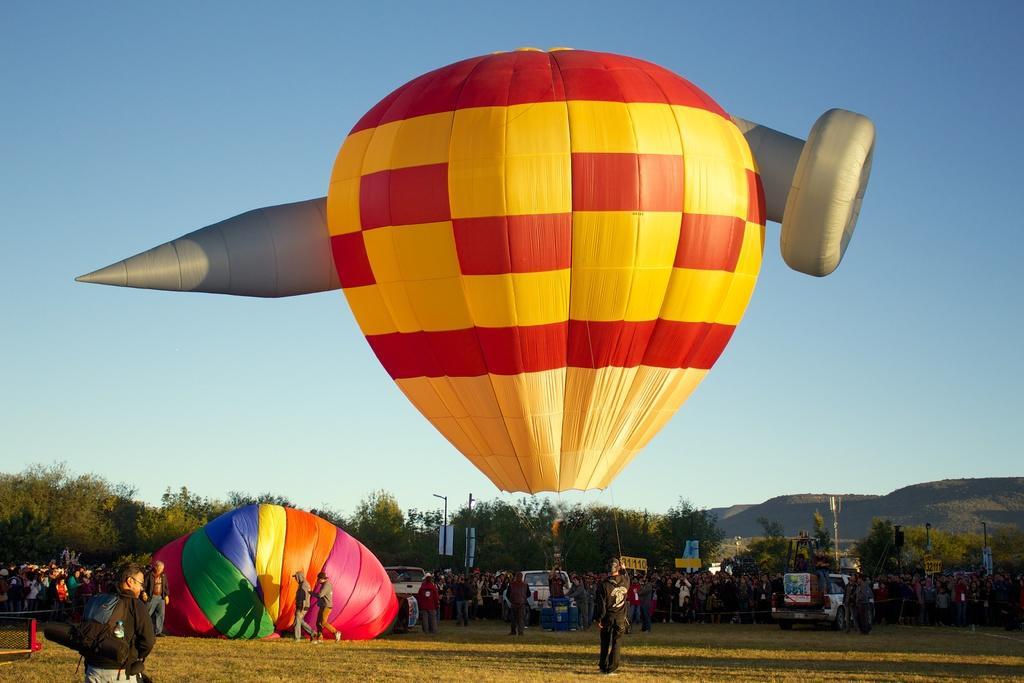How would you summarize this image in a sentence or two? In this image we can see many trees. There is a sky in the image. There are few vehicles in the image. There are few advertising boards in the image. There are few poles and many people in the image. 